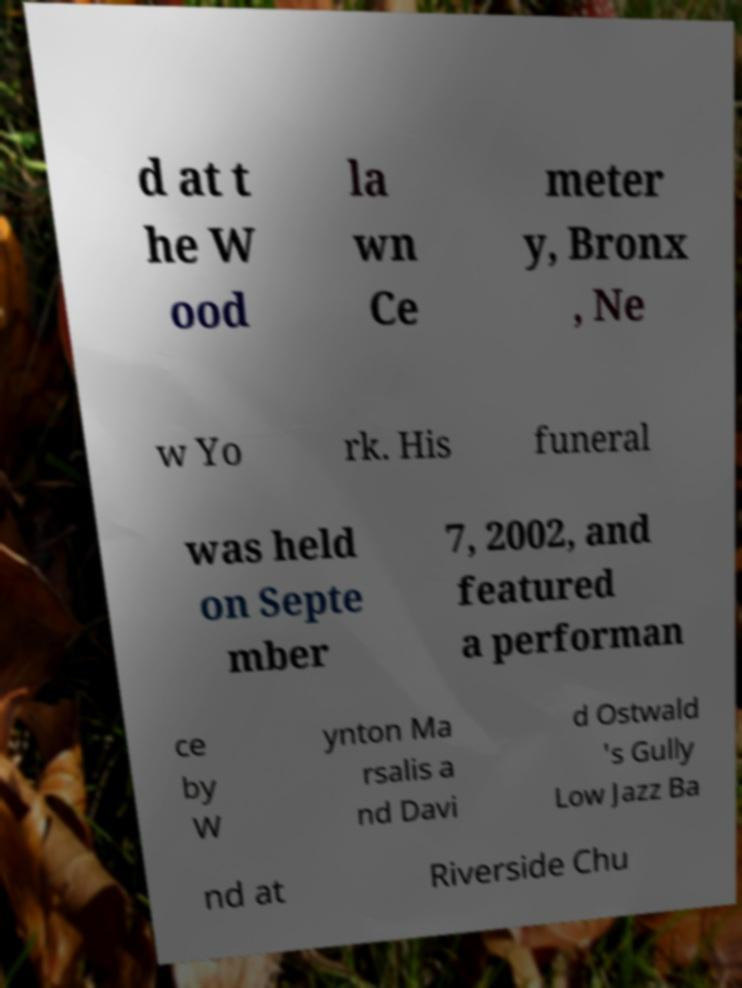I need the written content from this picture converted into text. Can you do that? d at t he W ood la wn Ce meter y, Bronx , Ne w Yo rk. His funeral was held on Septe mber 7, 2002, and featured a performan ce by W ynton Ma rsalis a nd Davi d Ostwald 's Gully Low Jazz Ba nd at Riverside Chu 